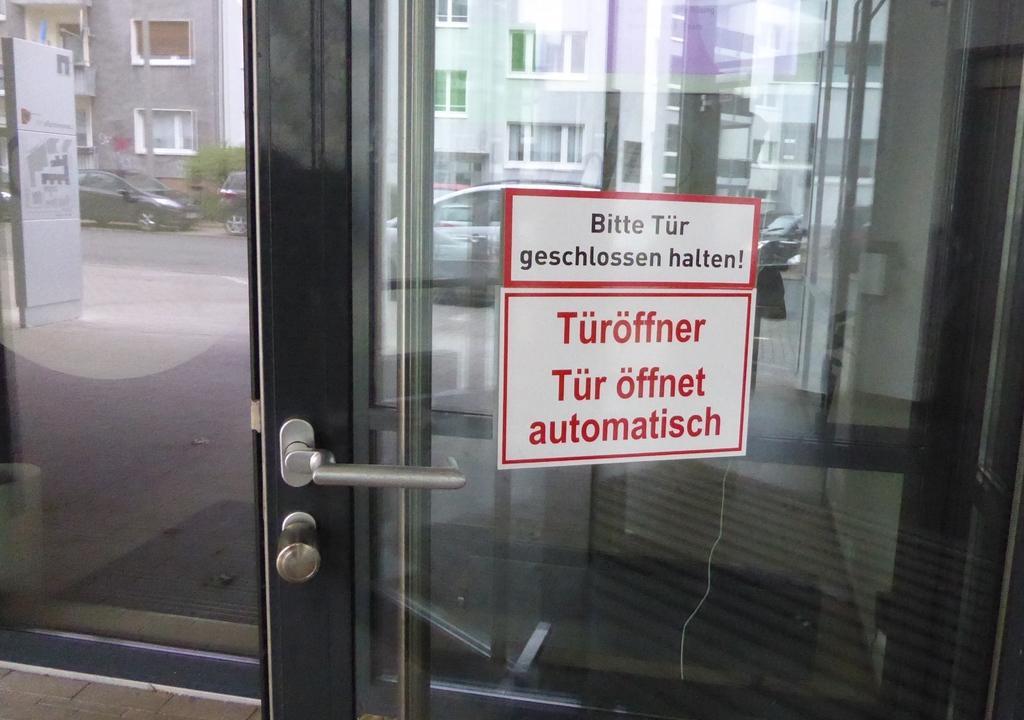In one or two sentences, can you explain what this image depicts? In this picture there is a door and there are posters on the door and there is text on the poster and there are reflections of buildings, trees and vehicles and there is a reflection of board and road on the door. Behind the door there is a mat. At the bottom there is a floor. 